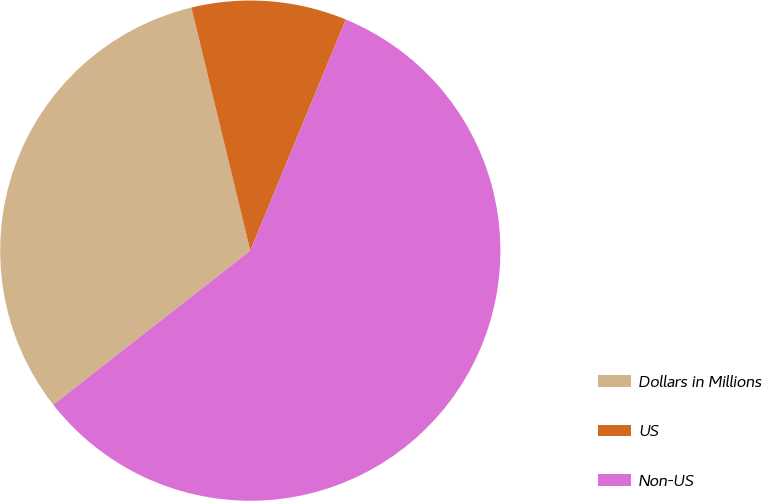Convert chart. <chart><loc_0><loc_0><loc_500><loc_500><pie_chart><fcel>Dollars in Millions<fcel>US<fcel>Non-US<nl><fcel>31.78%<fcel>10.02%<fcel>58.2%<nl></chart> 